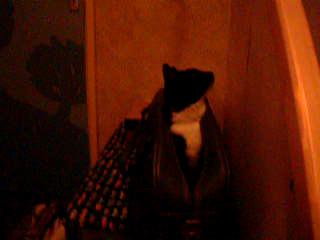Briefly describe the most prominent decoration in the image. A tree shape is painted on the wall, creating an interesting design element. Characterize the photograph's overall atmosphere and an important part of the scene. This dark, shadowy photo shows a black and white cat looking up toward a stairway. Mention the primary feline in the image along with its color and pose. There is a black and white cat in the bag, with its head turned towards the wall. Describe the most striking feature on the wall in the image. A large tree shape with a detailed design is painted on the wall. Portray the key living being in the photo and its activity. A black and white cat is resting within a patterned bag, attentively staring at a wall. Identify the primary animal in the image and its location. A black and white cat is inside a patterned bag, staring at the wall. Elaborate on the principal creature in the picture and its surroundings. A black and white cat is sitting inside a patterned bag with a wall featuring a painted tree behind it. Mention the key object in the picture and any noticeable feature on it. A black leather bag with a strap attachment can be seen, and a black and white cat is inside it. Explain the most distinguished object in the picture and what it's being used for. A patterned bag is holding a black and white cat that is staring at the wall. Point out the main architectural elements in the photo. A wooden door frame, white wooden guard rail, and beige wooden door framing are visible in the image. 